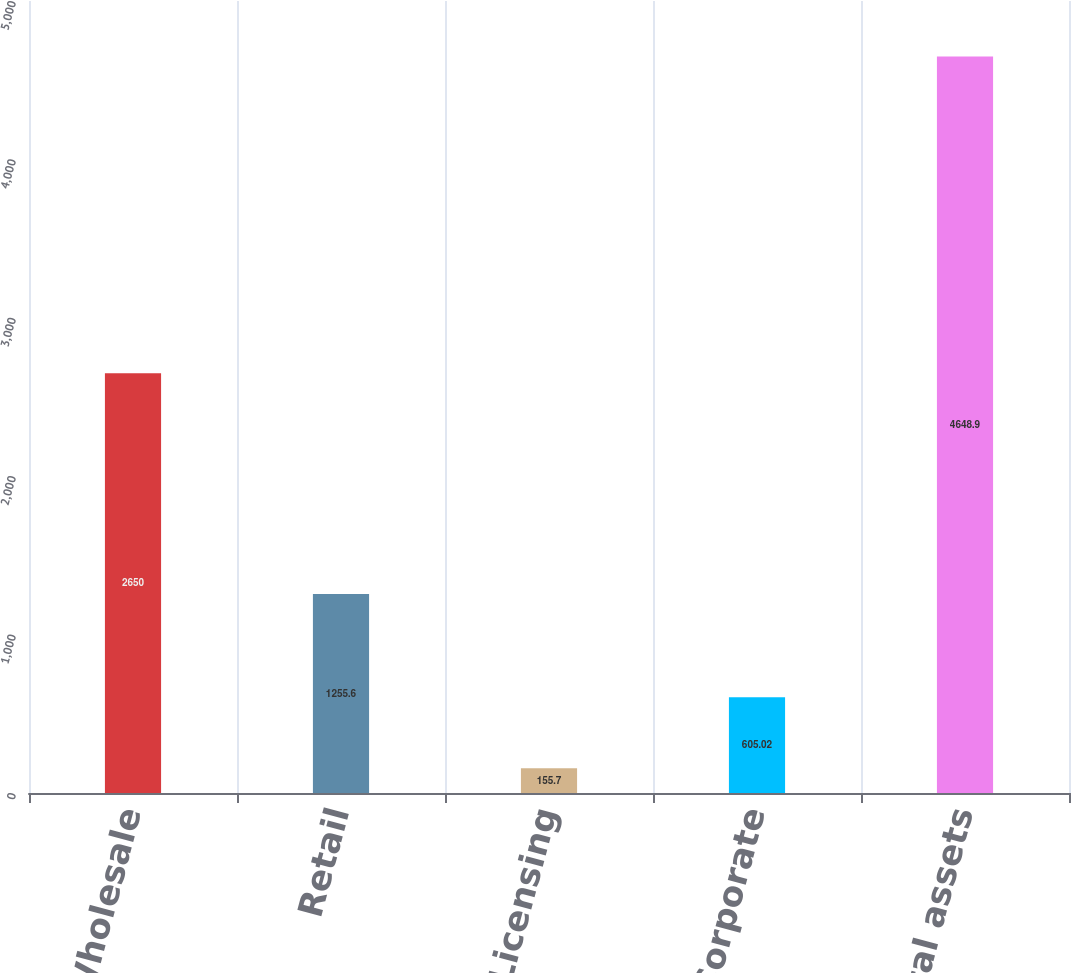Convert chart. <chart><loc_0><loc_0><loc_500><loc_500><bar_chart><fcel>Wholesale<fcel>Retail<fcel>Licensing<fcel>Corporate<fcel>Total assets<nl><fcel>2650<fcel>1255.6<fcel>155.7<fcel>605.02<fcel>4648.9<nl></chart> 